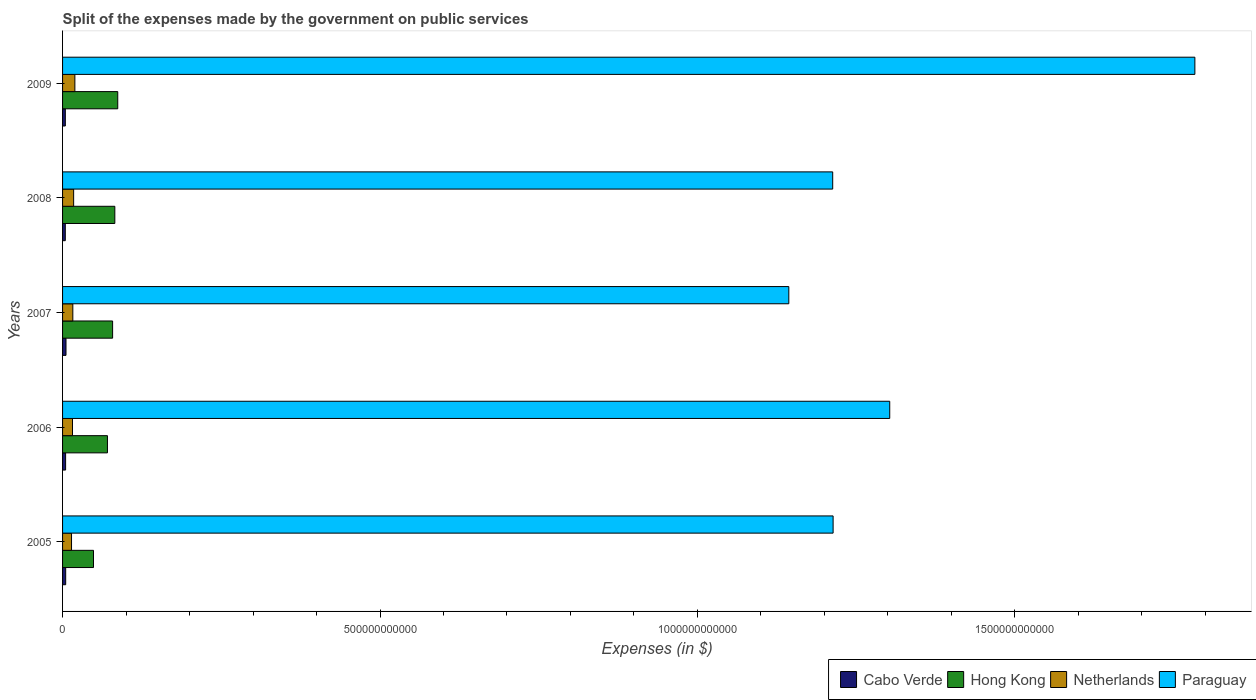How many different coloured bars are there?
Provide a short and direct response. 4. How many bars are there on the 3rd tick from the top?
Offer a terse response. 4. What is the expenses made by the government on public services in Paraguay in 2006?
Provide a succinct answer. 1.30e+12. Across all years, what is the maximum expenses made by the government on public services in Hong Kong?
Ensure brevity in your answer.  8.69e+1. Across all years, what is the minimum expenses made by the government on public services in Hong Kong?
Give a very brief answer. 4.87e+1. In which year was the expenses made by the government on public services in Cabo Verde maximum?
Ensure brevity in your answer.  2007. In which year was the expenses made by the government on public services in Cabo Verde minimum?
Provide a short and direct response. 2008. What is the total expenses made by the government on public services in Paraguay in the graph?
Offer a terse response. 6.66e+12. What is the difference between the expenses made by the government on public services in Paraguay in 2005 and that in 2007?
Offer a terse response. 6.98e+1. What is the difference between the expenses made by the government on public services in Paraguay in 2009 and the expenses made by the government on public services in Cabo Verde in 2007?
Offer a terse response. 1.78e+12. What is the average expenses made by the government on public services in Paraguay per year?
Provide a short and direct response. 1.33e+12. In the year 2007, what is the difference between the expenses made by the government on public services in Paraguay and expenses made by the government on public services in Cabo Verde?
Ensure brevity in your answer.  1.14e+12. What is the ratio of the expenses made by the government on public services in Paraguay in 2006 to that in 2008?
Provide a succinct answer. 1.07. Is the expenses made by the government on public services in Netherlands in 2007 less than that in 2009?
Your response must be concise. Yes. What is the difference between the highest and the second highest expenses made by the government on public services in Paraguay?
Ensure brevity in your answer.  4.81e+11. What is the difference between the highest and the lowest expenses made by the government on public services in Netherlands?
Your answer should be compact. 5.29e+09. In how many years, is the expenses made by the government on public services in Paraguay greater than the average expenses made by the government on public services in Paraguay taken over all years?
Offer a very short reply. 1. Is it the case that in every year, the sum of the expenses made by the government on public services in Netherlands and expenses made by the government on public services in Paraguay is greater than the sum of expenses made by the government on public services in Hong Kong and expenses made by the government on public services in Cabo Verde?
Your response must be concise. Yes. What does the 1st bar from the top in 2006 represents?
Keep it short and to the point. Paraguay. What does the 1st bar from the bottom in 2006 represents?
Your response must be concise. Cabo Verde. Is it the case that in every year, the sum of the expenses made by the government on public services in Paraguay and expenses made by the government on public services in Cabo Verde is greater than the expenses made by the government on public services in Hong Kong?
Your response must be concise. Yes. What is the difference between two consecutive major ticks on the X-axis?
Ensure brevity in your answer.  5.00e+11. Does the graph contain any zero values?
Offer a very short reply. No. How many legend labels are there?
Your answer should be very brief. 4. What is the title of the graph?
Offer a terse response. Split of the expenses made by the government on public services. What is the label or title of the X-axis?
Offer a very short reply. Expenses (in $). What is the Expenses (in $) in Cabo Verde in 2005?
Provide a succinct answer. 4.92e+09. What is the Expenses (in $) of Hong Kong in 2005?
Ensure brevity in your answer.  4.87e+1. What is the Expenses (in $) in Netherlands in 2005?
Your response must be concise. 1.41e+1. What is the Expenses (in $) in Paraguay in 2005?
Offer a terse response. 1.21e+12. What is the Expenses (in $) in Cabo Verde in 2006?
Ensure brevity in your answer.  4.79e+09. What is the Expenses (in $) in Hong Kong in 2006?
Your answer should be very brief. 7.07e+1. What is the Expenses (in $) of Netherlands in 2006?
Provide a short and direct response. 1.57e+1. What is the Expenses (in $) of Paraguay in 2006?
Your response must be concise. 1.30e+12. What is the Expenses (in $) of Cabo Verde in 2007?
Make the answer very short. 5.42e+09. What is the Expenses (in $) in Hong Kong in 2007?
Ensure brevity in your answer.  7.88e+1. What is the Expenses (in $) in Netherlands in 2007?
Your response must be concise. 1.62e+1. What is the Expenses (in $) of Paraguay in 2007?
Provide a succinct answer. 1.14e+12. What is the Expenses (in $) of Cabo Verde in 2008?
Provide a short and direct response. 4.31e+09. What is the Expenses (in $) of Hong Kong in 2008?
Ensure brevity in your answer.  8.23e+1. What is the Expenses (in $) in Netherlands in 2008?
Your answer should be very brief. 1.74e+1. What is the Expenses (in $) of Paraguay in 2008?
Offer a very short reply. 1.21e+12. What is the Expenses (in $) of Cabo Verde in 2009?
Your answer should be compact. 4.36e+09. What is the Expenses (in $) of Hong Kong in 2009?
Offer a very short reply. 8.69e+1. What is the Expenses (in $) in Netherlands in 2009?
Keep it short and to the point. 1.94e+1. What is the Expenses (in $) of Paraguay in 2009?
Provide a short and direct response. 1.78e+12. Across all years, what is the maximum Expenses (in $) of Cabo Verde?
Keep it short and to the point. 5.42e+09. Across all years, what is the maximum Expenses (in $) in Hong Kong?
Your answer should be very brief. 8.69e+1. Across all years, what is the maximum Expenses (in $) in Netherlands?
Keep it short and to the point. 1.94e+1. Across all years, what is the maximum Expenses (in $) in Paraguay?
Ensure brevity in your answer.  1.78e+12. Across all years, what is the minimum Expenses (in $) of Cabo Verde?
Give a very brief answer. 4.31e+09. Across all years, what is the minimum Expenses (in $) of Hong Kong?
Provide a succinct answer. 4.87e+1. Across all years, what is the minimum Expenses (in $) in Netherlands?
Your answer should be compact. 1.41e+1. Across all years, what is the minimum Expenses (in $) of Paraguay?
Offer a terse response. 1.14e+12. What is the total Expenses (in $) in Cabo Verde in the graph?
Make the answer very short. 2.38e+1. What is the total Expenses (in $) of Hong Kong in the graph?
Ensure brevity in your answer.  3.67e+11. What is the total Expenses (in $) of Netherlands in the graph?
Ensure brevity in your answer.  8.28e+1. What is the total Expenses (in $) in Paraguay in the graph?
Your response must be concise. 6.66e+12. What is the difference between the Expenses (in $) of Cabo Verde in 2005 and that in 2006?
Provide a succinct answer. 1.24e+08. What is the difference between the Expenses (in $) of Hong Kong in 2005 and that in 2006?
Offer a terse response. -2.20e+1. What is the difference between the Expenses (in $) of Netherlands in 2005 and that in 2006?
Your answer should be compact. -1.54e+09. What is the difference between the Expenses (in $) in Paraguay in 2005 and that in 2006?
Your answer should be very brief. -8.92e+1. What is the difference between the Expenses (in $) in Cabo Verde in 2005 and that in 2007?
Your answer should be very brief. -5.02e+08. What is the difference between the Expenses (in $) in Hong Kong in 2005 and that in 2007?
Your answer should be very brief. -3.01e+1. What is the difference between the Expenses (in $) of Netherlands in 2005 and that in 2007?
Your response must be concise. -2.05e+09. What is the difference between the Expenses (in $) in Paraguay in 2005 and that in 2007?
Your response must be concise. 6.98e+1. What is the difference between the Expenses (in $) of Cabo Verde in 2005 and that in 2008?
Your answer should be compact. 6.10e+08. What is the difference between the Expenses (in $) in Hong Kong in 2005 and that in 2008?
Your answer should be very brief. -3.36e+1. What is the difference between the Expenses (in $) in Netherlands in 2005 and that in 2008?
Your answer should be compact. -3.33e+09. What is the difference between the Expenses (in $) in Paraguay in 2005 and that in 2008?
Keep it short and to the point. 6.40e+08. What is the difference between the Expenses (in $) of Cabo Verde in 2005 and that in 2009?
Keep it short and to the point. 5.55e+08. What is the difference between the Expenses (in $) in Hong Kong in 2005 and that in 2009?
Offer a terse response. -3.82e+1. What is the difference between the Expenses (in $) in Netherlands in 2005 and that in 2009?
Ensure brevity in your answer.  -5.29e+09. What is the difference between the Expenses (in $) of Paraguay in 2005 and that in 2009?
Your answer should be compact. -5.70e+11. What is the difference between the Expenses (in $) in Cabo Verde in 2006 and that in 2007?
Offer a terse response. -6.26e+08. What is the difference between the Expenses (in $) of Hong Kong in 2006 and that in 2007?
Provide a short and direct response. -8.13e+09. What is the difference between the Expenses (in $) in Netherlands in 2006 and that in 2007?
Offer a terse response. -5.13e+08. What is the difference between the Expenses (in $) of Paraguay in 2006 and that in 2007?
Offer a terse response. 1.59e+11. What is the difference between the Expenses (in $) of Cabo Verde in 2006 and that in 2008?
Offer a terse response. 4.86e+08. What is the difference between the Expenses (in $) in Hong Kong in 2006 and that in 2008?
Provide a short and direct response. -1.16e+1. What is the difference between the Expenses (in $) in Netherlands in 2006 and that in 2008?
Provide a short and direct response. -1.79e+09. What is the difference between the Expenses (in $) in Paraguay in 2006 and that in 2008?
Your answer should be compact. 8.98e+1. What is the difference between the Expenses (in $) of Cabo Verde in 2006 and that in 2009?
Your answer should be compact. 4.31e+08. What is the difference between the Expenses (in $) of Hong Kong in 2006 and that in 2009?
Give a very brief answer. -1.62e+1. What is the difference between the Expenses (in $) in Netherlands in 2006 and that in 2009?
Offer a terse response. -3.74e+09. What is the difference between the Expenses (in $) of Paraguay in 2006 and that in 2009?
Ensure brevity in your answer.  -4.81e+11. What is the difference between the Expenses (in $) of Cabo Verde in 2007 and that in 2008?
Keep it short and to the point. 1.11e+09. What is the difference between the Expenses (in $) in Hong Kong in 2007 and that in 2008?
Provide a succinct answer. -3.48e+09. What is the difference between the Expenses (in $) of Netherlands in 2007 and that in 2008?
Your response must be concise. -1.28e+09. What is the difference between the Expenses (in $) in Paraguay in 2007 and that in 2008?
Keep it short and to the point. -6.91e+1. What is the difference between the Expenses (in $) in Cabo Verde in 2007 and that in 2009?
Provide a succinct answer. 1.06e+09. What is the difference between the Expenses (in $) of Hong Kong in 2007 and that in 2009?
Make the answer very short. -8.10e+09. What is the difference between the Expenses (in $) of Netherlands in 2007 and that in 2009?
Give a very brief answer. -3.23e+09. What is the difference between the Expenses (in $) in Paraguay in 2007 and that in 2009?
Your answer should be very brief. -6.40e+11. What is the difference between the Expenses (in $) of Cabo Verde in 2008 and that in 2009?
Provide a short and direct response. -5.47e+07. What is the difference between the Expenses (in $) in Hong Kong in 2008 and that in 2009?
Offer a very short reply. -4.62e+09. What is the difference between the Expenses (in $) in Netherlands in 2008 and that in 2009?
Make the answer very short. -1.95e+09. What is the difference between the Expenses (in $) of Paraguay in 2008 and that in 2009?
Make the answer very short. -5.70e+11. What is the difference between the Expenses (in $) in Cabo Verde in 2005 and the Expenses (in $) in Hong Kong in 2006?
Provide a succinct answer. -6.58e+1. What is the difference between the Expenses (in $) of Cabo Verde in 2005 and the Expenses (in $) of Netherlands in 2006?
Keep it short and to the point. -1.07e+1. What is the difference between the Expenses (in $) in Cabo Verde in 2005 and the Expenses (in $) in Paraguay in 2006?
Your answer should be compact. -1.30e+12. What is the difference between the Expenses (in $) of Hong Kong in 2005 and the Expenses (in $) of Netherlands in 2006?
Provide a succinct answer. 3.31e+1. What is the difference between the Expenses (in $) of Hong Kong in 2005 and the Expenses (in $) of Paraguay in 2006?
Provide a succinct answer. -1.25e+12. What is the difference between the Expenses (in $) of Netherlands in 2005 and the Expenses (in $) of Paraguay in 2006?
Offer a terse response. -1.29e+12. What is the difference between the Expenses (in $) of Cabo Verde in 2005 and the Expenses (in $) of Hong Kong in 2007?
Offer a terse response. -7.39e+1. What is the difference between the Expenses (in $) of Cabo Verde in 2005 and the Expenses (in $) of Netherlands in 2007?
Give a very brief answer. -1.13e+1. What is the difference between the Expenses (in $) in Cabo Verde in 2005 and the Expenses (in $) in Paraguay in 2007?
Provide a succinct answer. -1.14e+12. What is the difference between the Expenses (in $) of Hong Kong in 2005 and the Expenses (in $) of Netherlands in 2007?
Your answer should be very brief. 3.26e+1. What is the difference between the Expenses (in $) in Hong Kong in 2005 and the Expenses (in $) in Paraguay in 2007?
Keep it short and to the point. -1.10e+12. What is the difference between the Expenses (in $) in Netherlands in 2005 and the Expenses (in $) in Paraguay in 2007?
Ensure brevity in your answer.  -1.13e+12. What is the difference between the Expenses (in $) in Cabo Verde in 2005 and the Expenses (in $) in Hong Kong in 2008?
Provide a short and direct response. -7.74e+1. What is the difference between the Expenses (in $) of Cabo Verde in 2005 and the Expenses (in $) of Netherlands in 2008?
Provide a short and direct response. -1.25e+1. What is the difference between the Expenses (in $) of Cabo Verde in 2005 and the Expenses (in $) of Paraguay in 2008?
Your answer should be very brief. -1.21e+12. What is the difference between the Expenses (in $) of Hong Kong in 2005 and the Expenses (in $) of Netherlands in 2008?
Offer a terse response. 3.13e+1. What is the difference between the Expenses (in $) in Hong Kong in 2005 and the Expenses (in $) in Paraguay in 2008?
Provide a succinct answer. -1.16e+12. What is the difference between the Expenses (in $) in Netherlands in 2005 and the Expenses (in $) in Paraguay in 2008?
Ensure brevity in your answer.  -1.20e+12. What is the difference between the Expenses (in $) in Cabo Verde in 2005 and the Expenses (in $) in Hong Kong in 2009?
Ensure brevity in your answer.  -8.20e+1. What is the difference between the Expenses (in $) in Cabo Verde in 2005 and the Expenses (in $) in Netherlands in 2009?
Make the answer very short. -1.45e+1. What is the difference between the Expenses (in $) in Cabo Verde in 2005 and the Expenses (in $) in Paraguay in 2009?
Offer a very short reply. -1.78e+12. What is the difference between the Expenses (in $) in Hong Kong in 2005 and the Expenses (in $) in Netherlands in 2009?
Offer a very short reply. 2.93e+1. What is the difference between the Expenses (in $) in Hong Kong in 2005 and the Expenses (in $) in Paraguay in 2009?
Your answer should be very brief. -1.73e+12. What is the difference between the Expenses (in $) in Netherlands in 2005 and the Expenses (in $) in Paraguay in 2009?
Ensure brevity in your answer.  -1.77e+12. What is the difference between the Expenses (in $) of Cabo Verde in 2006 and the Expenses (in $) of Hong Kong in 2007?
Your answer should be compact. -7.40e+1. What is the difference between the Expenses (in $) in Cabo Verde in 2006 and the Expenses (in $) in Netherlands in 2007?
Your answer should be compact. -1.14e+1. What is the difference between the Expenses (in $) of Cabo Verde in 2006 and the Expenses (in $) of Paraguay in 2007?
Offer a terse response. -1.14e+12. What is the difference between the Expenses (in $) in Hong Kong in 2006 and the Expenses (in $) in Netherlands in 2007?
Your answer should be very brief. 5.45e+1. What is the difference between the Expenses (in $) of Hong Kong in 2006 and the Expenses (in $) of Paraguay in 2007?
Give a very brief answer. -1.07e+12. What is the difference between the Expenses (in $) in Netherlands in 2006 and the Expenses (in $) in Paraguay in 2007?
Make the answer very short. -1.13e+12. What is the difference between the Expenses (in $) of Cabo Verde in 2006 and the Expenses (in $) of Hong Kong in 2008?
Provide a short and direct response. -7.75e+1. What is the difference between the Expenses (in $) in Cabo Verde in 2006 and the Expenses (in $) in Netherlands in 2008?
Offer a terse response. -1.27e+1. What is the difference between the Expenses (in $) in Cabo Verde in 2006 and the Expenses (in $) in Paraguay in 2008?
Give a very brief answer. -1.21e+12. What is the difference between the Expenses (in $) of Hong Kong in 2006 and the Expenses (in $) of Netherlands in 2008?
Make the answer very short. 5.33e+1. What is the difference between the Expenses (in $) of Hong Kong in 2006 and the Expenses (in $) of Paraguay in 2008?
Ensure brevity in your answer.  -1.14e+12. What is the difference between the Expenses (in $) in Netherlands in 2006 and the Expenses (in $) in Paraguay in 2008?
Make the answer very short. -1.20e+12. What is the difference between the Expenses (in $) of Cabo Verde in 2006 and the Expenses (in $) of Hong Kong in 2009?
Your answer should be very brief. -8.21e+1. What is the difference between the Expenses (in $) in Cabo Verde in 2006 and the Expenses (in $) in Netherlands in 2009?
Provide a short and direct response. -1.46e+1. What is the difference between the Expenses (in $) of Cabo Verde in 2006 and the Expenses (in $) of Paraguay in 2009?
Ensure brevity in your answer.  -1.78e+12. What is the difference between the Expenses (in $) in Hong Kong in 2006 and the Expenses (in $) in Netherlands in 2009?
Offer a terse response. 5.13e+1. What is the difference between the Expenses (in $) in Hong Kong in 2006 and the Expenses (in $) in Paraguay in 2009?
Your response must be concise. -1.71e+12. What is the difference between the Expenses (in $) in Netherlands in 2006 and the Expenses (in $) in Paraguay in 2009?
Your response must be concise. -1.77e+12. What is the difference between the Expenses (in $) of Cabo Verde in 2007 and the Expenses (in $) of Hong Kong in 2008?
Give a very brief answer. -7.69e+1. What is the difference between the Expenses (in $) of Cabo Verde in 2007 and the Expenses (in $) of Netherlands in 2008?
Provide a short and direct response. -1.20e+1. What is the difference between the Expenses (in $) in Cabo Verde in 2007 and the Expenses (in $) in Paraguay in 2008?
Give a very brief answer. -1.21e+12. What is the difference between the Expenses (in $) in Hong Kong in 2007 and the Expenses (in $) in Netherlands in 2008?
Offer a very short reply. 6.14e+1. What is the difference between the Expenses (in $) in Hong Kong in 2007 and the Expenses (in $) in Paraguay in 2008?
Offer a very short reply. -1.13e+12. What is the difference between the Expenses (in $) of Netherlands in 2007 and the Expenses (in $) of Paraguay in 2008?
Offer a very short reply. -1.20e+12. What is the difference between the Expenses (in $) in Cabo Verde in 2007 and the Expenses (in $) in Hong Kong in 2009?
Ensure brevity in your answer.  -8.15e+1. What is the difference between the Expenses (in $) of Cabo Verde in 2007 and the Expenses (in $) of Netherlands in 2009?
Ensure brevity in your answer.  -1.40e+1. What is the difference between the Expenses (in $) of Cabo Verde in 2007 and the Expenses (in $) of Paraguay in 2009?
Offer a very short reply. -1.78e+12. What is the difference between the Expenses (in $) of Hong Kong in 2007 and the Expenses (in $) of Netherlands in 2009?
Keep it short and to the point. 5.94e+1. What is the difference between the Expenses (in $) in Hong Kong in 2007 and the Expenses (in $) in Paraguay in 2009?
Your answer should be very brief. -1.70e+12. What is the difference between the Expenses (in $) in Netherlands in 2007 and the Expenses (in $) in Paraguay in 2009?
Give a very brief answer. -1.77e+12. What is the difference between the Expenses (in $) in Cabo Verde in 2008 and the Expenses (in $) in Hong Kong in 2009?
Give a very brief answer. -8.26e+1. What is the difference between the Expenses (in $) in Cabo Verde in 2008 and the Expenses (in $) in Netherlands in 2009?
Provide a succinct answer. -1.51e+1. What is the difference between the Expenses (in $) of Cabo Verde in 2008 and the Expenses (in $) of Paraguay in 2009?
Your response must be concise. -1.78e+12. What is the difference between the Expenses (in $) in Hong Kong in 2008 and the Expenses (in $) in Netherlands in 2009?
Make the answer very short. 6.29e+1. What is the difference between the Expenses (in $) of Hong Kong in 2008 and the Expenses (in $) of Paraguay in 2009?
Make the answer very short. -1.70e+12. What is the difference between the Expenses (in $) in Netherlands in 2008 and the Expenses (in $) in Paraguay in 2009?
Provide a short and direct response. -1.77e+12. What is the average Expenses (in $) in Cabo Verde per year?
Your response must be concise. 4.76e+09. What is the average Expenses (in $) of Hong Kong per year?
Make the answer very short. 7.35e+1. What is the average Expenses (in $) in Netherlands per year?
Provide a succinct answer. 1.66e+1. What is the average Expenses (in $) of Paraguay per year?
Make the answer very short. 1.33e+12. In the year 2005, what is the difference between the Expenses (in $) in Cabo Verde and Expenses (in $) in Hong Kong?
Your answer should be very brief. -4.38e+1. In the year 2005, what is the difference between the Expenses (in $) in Cabo Verde and Expenses (in $) in Netherlands?
Make the answer very short. -9.20e+09. In the year 2005, what is the difference between the Expenses (in $) of Cabo Verde and Expenses (in $) of Paraguay?
Ensure brevity in your answer.  -1.21e+12. In the year 2005, what is the difference between the Expenses (in $) of Hong Kong and Expenses (in $) of Netherlands?
Your answer should be compact. 3.46e+1. In the year 2005, what is the difference between the Expenses (in $) in Hong Kong and Expenses (in $) in Paraguay?
Your answer should be very brief. -1.16e+12. In the year 2005, what is the difference between the Expenses (in $) of Netherlands and Expenses (in $) of Paraguay?
Offer a very short reply. -1.20e+12. In the year 2006, what is the difference between the Expenses (in $) in Cabo Verde and Expenses (in $) in Hong Kong?
Make the answer very short. -6.59e+1. In the year 2006, what is the difference between the Expenses (in $) of Cabo Verde and Expenses (in $) of Netherlands?
Ensure brevity in your answer.  -1.09e+1. In the year 2006, what is the difference between the Expenses (in $) of Cabo Verde and Expenses (in $) of Paraguay?
Give a very brief answer. -1.30e+12. In the year 2006, what is the difference between the Expenses (in $) in Hong Kong and Expenses (in $) in Netherlands?
Your answer should be compact. 5.50e+1. In the year 2006, what is the difference between the Expenses (in $) of Hong Kong and Expenses (in $) of Paraguay?
Offer a very short reply. -1.23e+12. In the year 2006, what is the difference between the Expenses (in $) of Netherlands and Expenses (in $) of Paraguay?
Provide a succinct answer. -1.29e+12. In the year 2007, what is the difference between the Expenses (in $) in Cabo Verde and Expenses (in $) in Hong Kong?
Your answer should be compact. -7.34e+1. In the year 2007, what is the difference between the Expenses (in $) in Cabo Verde and Expenses (in $) in Netherlands?
Provide a short and direct response. -1.07e+1. In the year 2007, what is the difference between the Expenses (in $) of Cabo Verde and Expenses (in $) of Paraguay?
Offer a very short reply. -1.14e+12. In the year 2007, what is the difference between the Expenses (in $) in Hong Kong and Expenses (in $) in Netherlands?
Give a very brief answer. 6.27e+1. In the year 2007, what is the difference between the Expenses (in $) in Hong Kong and Expenses (in $) in Paraguay?
Make the answer very short. -1.07e+12. In the year 2007, what is the difference between the Expenses (in $) in Netherlands and Expenses (in $) in Paraguay?
Your response must be concise. -1.13e+12. In the year 2008, what is the difference between the Expenses (in $) in Cabo Verde and Expenses (in $) in Hong Kong?
Your answer should be very brief. -7.80e+1. In the year 2008, what is the difference between the Expenses (in $) of Cabo Verde and Expenses (in $) of Netherlands?
Offer a very short reply. -1.31e+1. In the year 2008, what is the difference between the Expenses (in $) of Cabo Verde and Expenses (in $) of Paraguay?
Your answer should be compact. -1.21e+12. In the year 2008, what is the difference between the Expenses (in $) in Hong Kong and Expenses (in $) in Netherlands?
Your answer should be compact. 6.49e+1. In the year 2008, what is the difference between the Expenses (in $) of Hong Kong and Expenses (in $) of Paraguay?
Provide a short and direct response. -1.13e+12. In the year 2008, what is the difference between the Expenses (in $) in Netherlands and Expenses (in $) in Paraguay?
Your answer should be very brief. -1.20e+12. In the year 2009, what is the difference between the Expenses (in $) in Cabo Verde and Expenses (in $) in Hong Kong?
Make the answer very short. -8.26e+1. In the year 2009, what is the difference between the Expenses (in $) in Cabo Verde and Expenses (in $) in Netherlands?
Give a very brief answer. -1.50e+1. In the year 2009, what is the difference between the Expenses (in $) of Cabo Verde and Expenses (in $) of Paraguay?
Offer a terse response. -1.78e+12. In the year 2009, what is the difference between the Expenses (in $) of Hong Kong and Expenses (in $) of Netherlands?
Provide a succinct answer. 6.75e+1. In the year 2009, what is the difference between the Expenses (in $) in Hong Kong and Expenses (in $) in Paraguay?
Offer a terse response. -1.70e+12. In the year 2009, what is the difference between the Expenses (in $) in Netherlands and Expenses (in $) in Paraguay?
Your answer should be compact. -1.76e+12. What is the ratio of the Expenses (in $) of Cabo Verde in 2005 to that in 2006?
Your answer should be compact. 1.03. What is the ratio of the Expenses (in $) of Hong Kong in 2005 to that in 2006?
Make the answer very short. 0.69. What is the ratio of the Expenses (in $) in Netherlands in 2005 to that in 2006?
Provide a succinct answer. 0.9. What is the ratio of the Expenses (in $) in Paraguay in 2005 to that in 2006?
Make the answer very short. 0.93. What is the ratio of the Expenses (in $) of Cabo Verde in 2005 to that in 2007?
Your answer should be compact. 0.91. What is the ratio of the Expenses (in $) of Hong Kong in 2005 to that in 2007?
Your response must be concise. 0.62. What is the ratio of the Expenses (in $) in Netherlands in 2005 to that in 2007?
Your answer should be compact. 0.87. What is the ratio of the Expenses (in $) of Paraguay in 2005 to that in 2007?
Provide a short and direct response. 1.06. What is the ratio of the Expenses (in $) in Cabo Verde in 2005 to that in 2008?
Your answer should be very brief. 1.14. What is the ratio of the Expenses (in $) of Hong Kong in 2005 to that in 2008?
Offer a terse response. 0.59. What is the ratio of the Expenses (in $) of Netherlands in 2005 to that in 2008?
Provide a succinct answer. 0.81. What is the ratio of the Expenses (in $) in Cabo Verde in 2005 to that in 2009?
Keep it short and to the point. 1.13. What is the ratio of the Expenses (in $) of Hong Kong in 2005 to that in 2009?
Give a very brief answer. 0.56. What is the ratio of the Expenses (in $) in Netherlands in 2005 to that in 2009?
Ensure brevity in your answer.  0.73. What is the ratio of the Expenses (in $) in Paraguay in 2005 to that in 2009?
Make the answer very short. 0.68. What is the ratio of the Expenses (in $) of Cabo Verde in 2006 to that in 2007?
Provide a short and direct response. 0.88. What is the ratio of the Expenses (in $) of Hong Kong in 2006 to that in 2007?
Provide a succinct answer. 0.9. What is the ratio of the Expenses (in $) of Netherlands in 2006 to that in 2007?
Keep it short and to the point. 0.97. What is the ratio of the Expenses (in $) of Paraguay in 2006 to that in 2007?
Give a very brief answer. 1.14. What is the ratio of the Expenses (in $) of Cabo Verde in 2006 to that in 2008?
Your answer should be very brief. 1.11. What is the ratio of the Expenses (in $) of Hong Kong in 2006 to that in 2008?
Your answer should be very brief. 0.86. What is the ratio of the Expenses (in $) of Netherlands in 2006 to that in 2008?
Ensure brevity in your answer.  0.9. What is the ratio of the Expenses (in $) in Paraguay in 2006 to that in 2008?
Make the answer very short. 1.07. What is the ratio of the Expenses (in $) in Cabo Verde in 2006 to that in 2009?
Give a very brief answer. 1.1. What is the ratio of the Expenses (in $) in Hong Kong in 2006 to that in 2009?
Your answer should be compact. 0.81. What is the ratio of the Expenses (in $) of Netherlands in 2006 to that in 2009?
Give a very brief answer. 0.81. What is the ratio of the Expenses (in $) in Paraguay in 2006 to that in 2009?
Make the answer very short. 0.73. What is the ratio of the Expenses (in $) of Cabo Verde in 2007 to that in 2008?
Your answer should be compact. 1.26. What is the ratio of the Expenses (in $) of Hong Kong in 2007 to that in 2008?
Provide a succinct answer. 0.96. What is the ratio of the Expenses (in $) of Netherlands in 2007 to that in 2008?
Give a very brief answer. 0.93. What is the ratio of the Expenses (in $) in Paraguay in 2007 to that in 2008?
Keep it short and to the point. 0.94. What is the ratio of the Expenses (in $) of Cabo Verde in 2007 to that in 2009?
Make the answer very short. 1.24. What is the ratio of the Expenses (in $) of Hong Kong in 2007 to that in 2009?
Provide a succinct answer. 0.91. What is the ratio of the Expenses (in $) in Netherlands in 2007 to that in 2009?
Your answer should be very brief. 0.83. What is the ratio of the Expenses (in $) in Paraguay in 2007 to that in 2009?
Your response must be concise. 0.64. What is the ratio of the Expenses (in $) in Cabo Verde in 2008 to that in 2009?
Offer a terse response. 0.99. What is the ratio of the Expenses (in $) in Hong Kong in 2008 to that in 2009?
Keep it short and to the point. 0.95. What is the ratio of the Expenses (in $) of Netherlands in 2008 to that in 2009?
Give a very brief answer. 0.9. What is the ratio of the Expenses (in $) in Paraguay in 2008 to that in 2009?
Ensure brevity in your answer.  0.68. What is the difference between the highest and the second highest Expenses (in $) of Cabo Verde?
Your answer should be compact. 5.02e+08. What is the difference between the highest and the second highest Expenses (in $) in Hong Kong?
Provide a short and direct response. 4.62e+09. What is the difference between the highest and the second highest Expenses (in $) of Netherlands?
Your answer should be compact. 1.95e+09. What is the difference between the highest and the second highest Expenses (in $) in Paraguay?
Provide a succinct answer. 4.81e+11. What is the difference between the highest and the lowest Expenses (in $) of Cabo Verde?
Make the answer very short. 1.11e+09. What is the difference between the highest and the lowest Expenses (in $) of Hong Kong?
Give a very brief answer. 3.82e+1. What is the difference between the highest and the lowest Expenses (in $) of Netherlands?
Offer a terse response. 5.29e+09. What is the difference between the highest and the lowest Expenses (in $) of Paraguay?
Provide a succinct answer. 6.40e+11. 